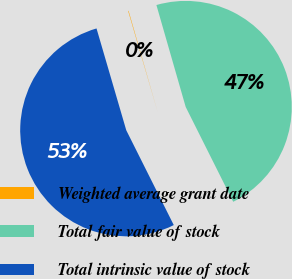Convert chart. <chart><loc_0><loc_0><loc_500><loc_500><pie_chart><fcel>Weighted average grant date<fcel>Total fair value of stock<fcel>Total intrinsic value of stock<nl><fcel>0.07%<fcel>47.06%<fcel>52.87%<nl></chart> 